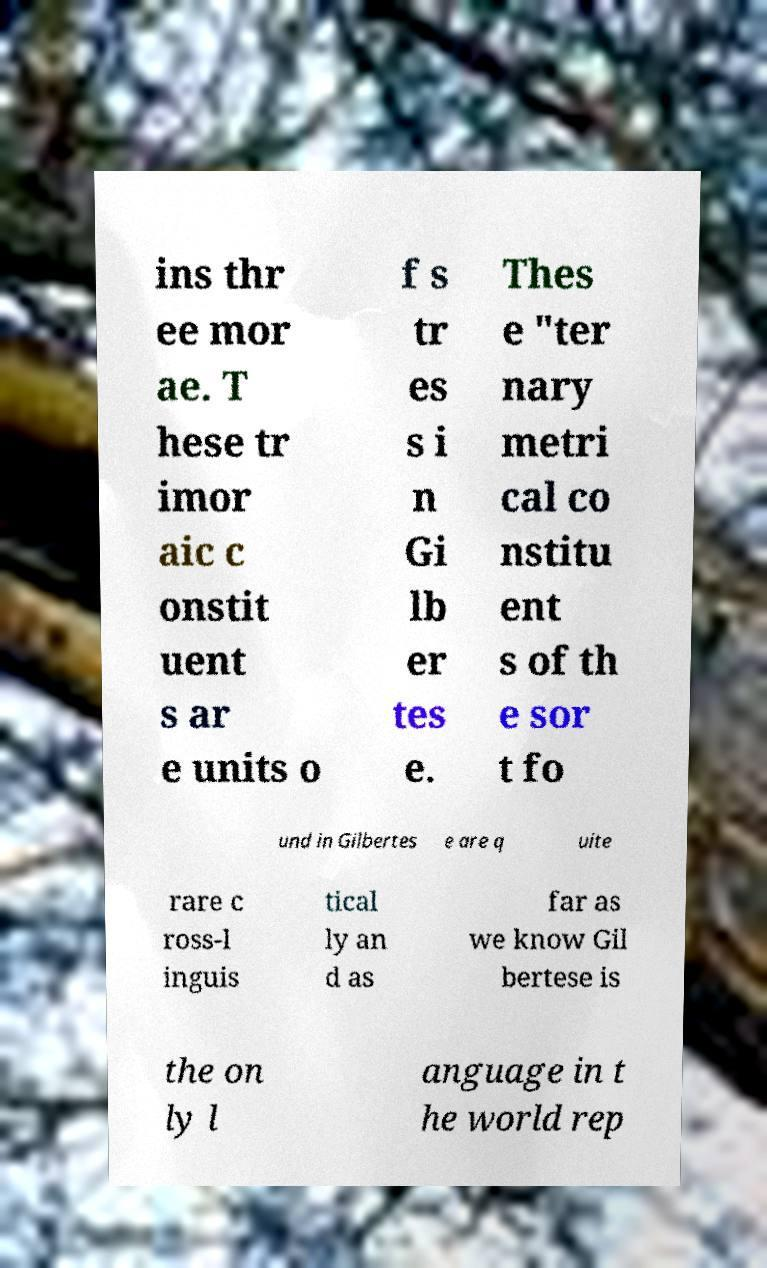Please read and relay the text visible in this image. What does it say? ins thr ee mor ae. T hese tr imor aic c onstit uent s ar e units o f s tr es s i n Gi lb er tes e. Thes e "ter nary metri cal co nstitu ent s of th e sor t fo und in Gilbertes e are q uite rare c ross-l inguis tical ly an d as far as we know Gil bertese is the on ly l anguage in t he world rep 